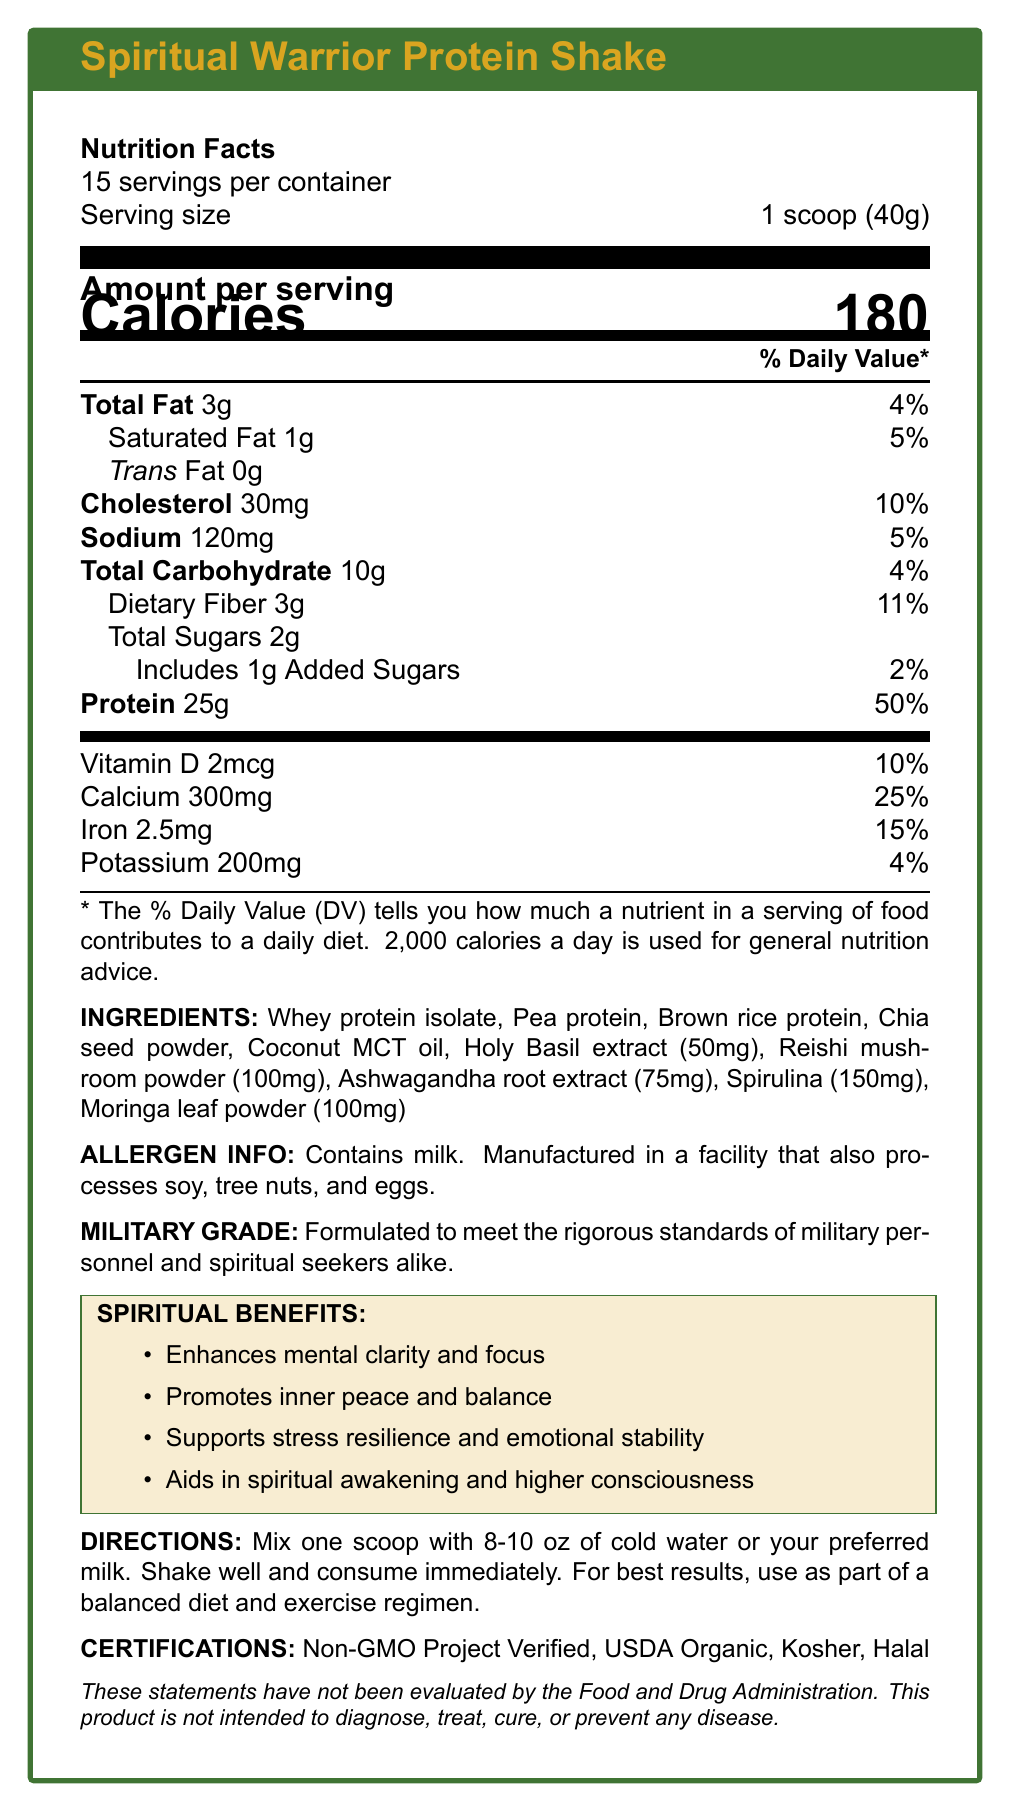what is the serving size? The serving size is listed as "1 scoop (40g)" in the Nutrition Facts section.
Answer: 1 scoop (40g) how many calories are there per serving? The document states that there are 180 calories per serving.
Answer: 180 what percentage of daily value is the protein content? The % Daily Value for protein is given as 50%.
Answer: 50% which vitamin has the highest % daily value? A. Vitamin D B. Calcium C. Iron D. Potassium Calcium has a 25% daily value, which is higher than Vitamin D (10%), Iron (15%), and Potassium (4%).
Answer: B does the product contain trans fat? The document lists "Trans Fat 0g," indicating there is no trans fat.
Answer: No how many servings are in the container? The document indicates there are 15 servings per container.
Answer: 15 what are the spiritual benefits of the product? The document lists four spiritual benefits: Enhances mental clarity and focus, Promotes inner peace and balance, Supports stress resilience and emotional stability, Aids in spiritual awakening and higher consciousness.
Answer: Enhances mental clarity and focus, Promotes inner peace and balance, Supports stress resilience and emotional stability, Aids in spiritual awakening and higher consciousness what are the main ingredients of the product? The main ingredients listed are Whey protein isolate, Pea protein, Brown rice protein, Chia seed powder, and Coconut MCT oil.
Answer: Whey protein isolate, Pea protein, Brown rice protein, Chia seed powder, Coconut MCT oil what is the amount of dietary fiber per serving? The document states that there is 3g of dietary fiber per serving.
Answer: 3g which spiritual ingredient is present in the highest amount? A. Holy Basil extract B. Reishi mushroom powder C. Ashwagandha root extract D. Spirulina Spirulina is listed at 150mg, which is higher than the amounts for Holy Basil extract (50mg), Reishi mushroom powder (100mg), and Ashwagandha root extract (75mg).
Answer: D does the product contain any allergens? The document states that the product contains milk and is manufactured in a facility that also processes soy, tree nuts, and eggs.
Answer: Yes what does the disclaimer say about the product's evaluation by the FDA? The disclaimer states that the statements have not been evaluated by the FDA.
Answer: These statements have not been evaluated by the Food and Drug Administration. where are the ingredients sourced from? The document mentions that all ingredients are ethically sourced and fairly traded.
Answer: All ingredients are ethically sourced and fairly traded. is the packaging environmentally friendly? The document states that the packaging is made from 100% recycled materials and is fully biodegradable.
Answer: Yes what certifications does the product have? The product has certifications including Non-GMO Project Verified, USDA Organic, Kosher, and Halal.
Answer: Non-GMO Project Verified, USDA Organic, Kosher, Halal how should the product be consumed for best results? The directions specify mixing one scoop with 8-10 oz of cold water or preferred milk, shaking well, and consuming immediately. It should be used as part of a balanced diet and exercise regimen.
Answer: Mix one scoop with 8-10 oz of cold water or preferred milk, shake well, and consume immediately. Use as part of a balanced diet and exercise regimen. describe the entire document. The document provides a detailed summary of the nutritional contents, ingredients, spiritual benefits, and product certifications, along with guidelines for usage and information on ethical sourcing and environmental impact.
Answer: The document is a comprehensive Nutrition Facts Label for the "Spiritual Warrior Protein Shake." It provides detailed nutritional information such as calories, fat, cholesterol, sodium, carbohydrates, and protein content per serving. It lists both main and spiritual ingredients, along with their amounts. The document also covers allergen information, spiritual benefits, usage directions, certifications, ethical sourcing, and environmental impact statements. Additionally, it includes a military-grade statement and a disclaimer on FDA evaluation. what are the three lowest % daily values listed for micronutrients? The % Daily Values for Vitamin D (10%), Potassium (4%), and Iron (15%) are the lowest among the listed micronutrients.
Answer: Vitamin D (10%), Potassium (4%), Iron (15%) how many grams of total carbohydrates are in one serving? The document states that there are 10g of total carbohydrates per serving.
Answer: 10g what is the exact amount of cholesterol per serving? A. 20mg B. 25mg C. 30mg D. 35mg The document lists the amount of cholesterol per serving as 30mg.
Answer: C what is the combined amount of protein in one serving from the different sources listed? The document lists various sources of protein but does not provide an exact breakdown of how much protein comes from each source (Whey protein isolate, Pea protein, Brown rice protein, etc.), making it impossible to determine the combined amount from each source exactly.
Answer: Cannot be determined 